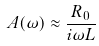Convert formula to latex. <formula><loc_0><loc_0><loc_500><loc_500>A ( \omega ) \approx \frac { R _ { 0 } } { i \omega L }</formula> 